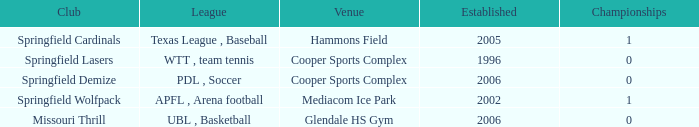What are the highest championships where the club is Springfield Cardinals? 1.0. Can you give me this table as a dict? {'header': ['Club', 'League', 'Venue', 'Established', 'Championships'], 'rows': [['Springfield Cardinals', 'Texas League , Baseball', 'Hammons Field', '2005', '1'], ['Springfield Lasers', 'WTT , team tennis', 'Cooper Sports Complex', '1996', '0'], ['Springfield Demize', 'PDL , Soccer', 'Cooper Sports Complex', '2006', '0'], ['Springfield Wolfpack', 'APFL , Arena football', 'Mediacom Ice Park', '2002', '1'], ['Missouri Thrill', 'UBL , Basketball', 'Glendale HS Gym', '2006', '0']]} 